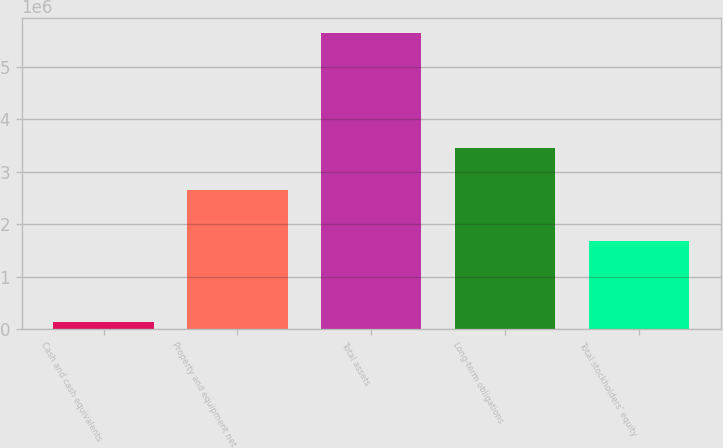<chart> <loc_0><loc_0><loc_500><loc_500><bar_chart><fcel>Cash and cash equivalents<fcel>Property and equipment net<fcel>Total assets<fcel>Long-term obligations<fcel>Total stockholders' equity<nl><fcel>127292<fcel>2.65049e+06<fcel>5.64369e+06<fcel>3.44851e+06<fcel>1.67559e+06<nl></chart> 